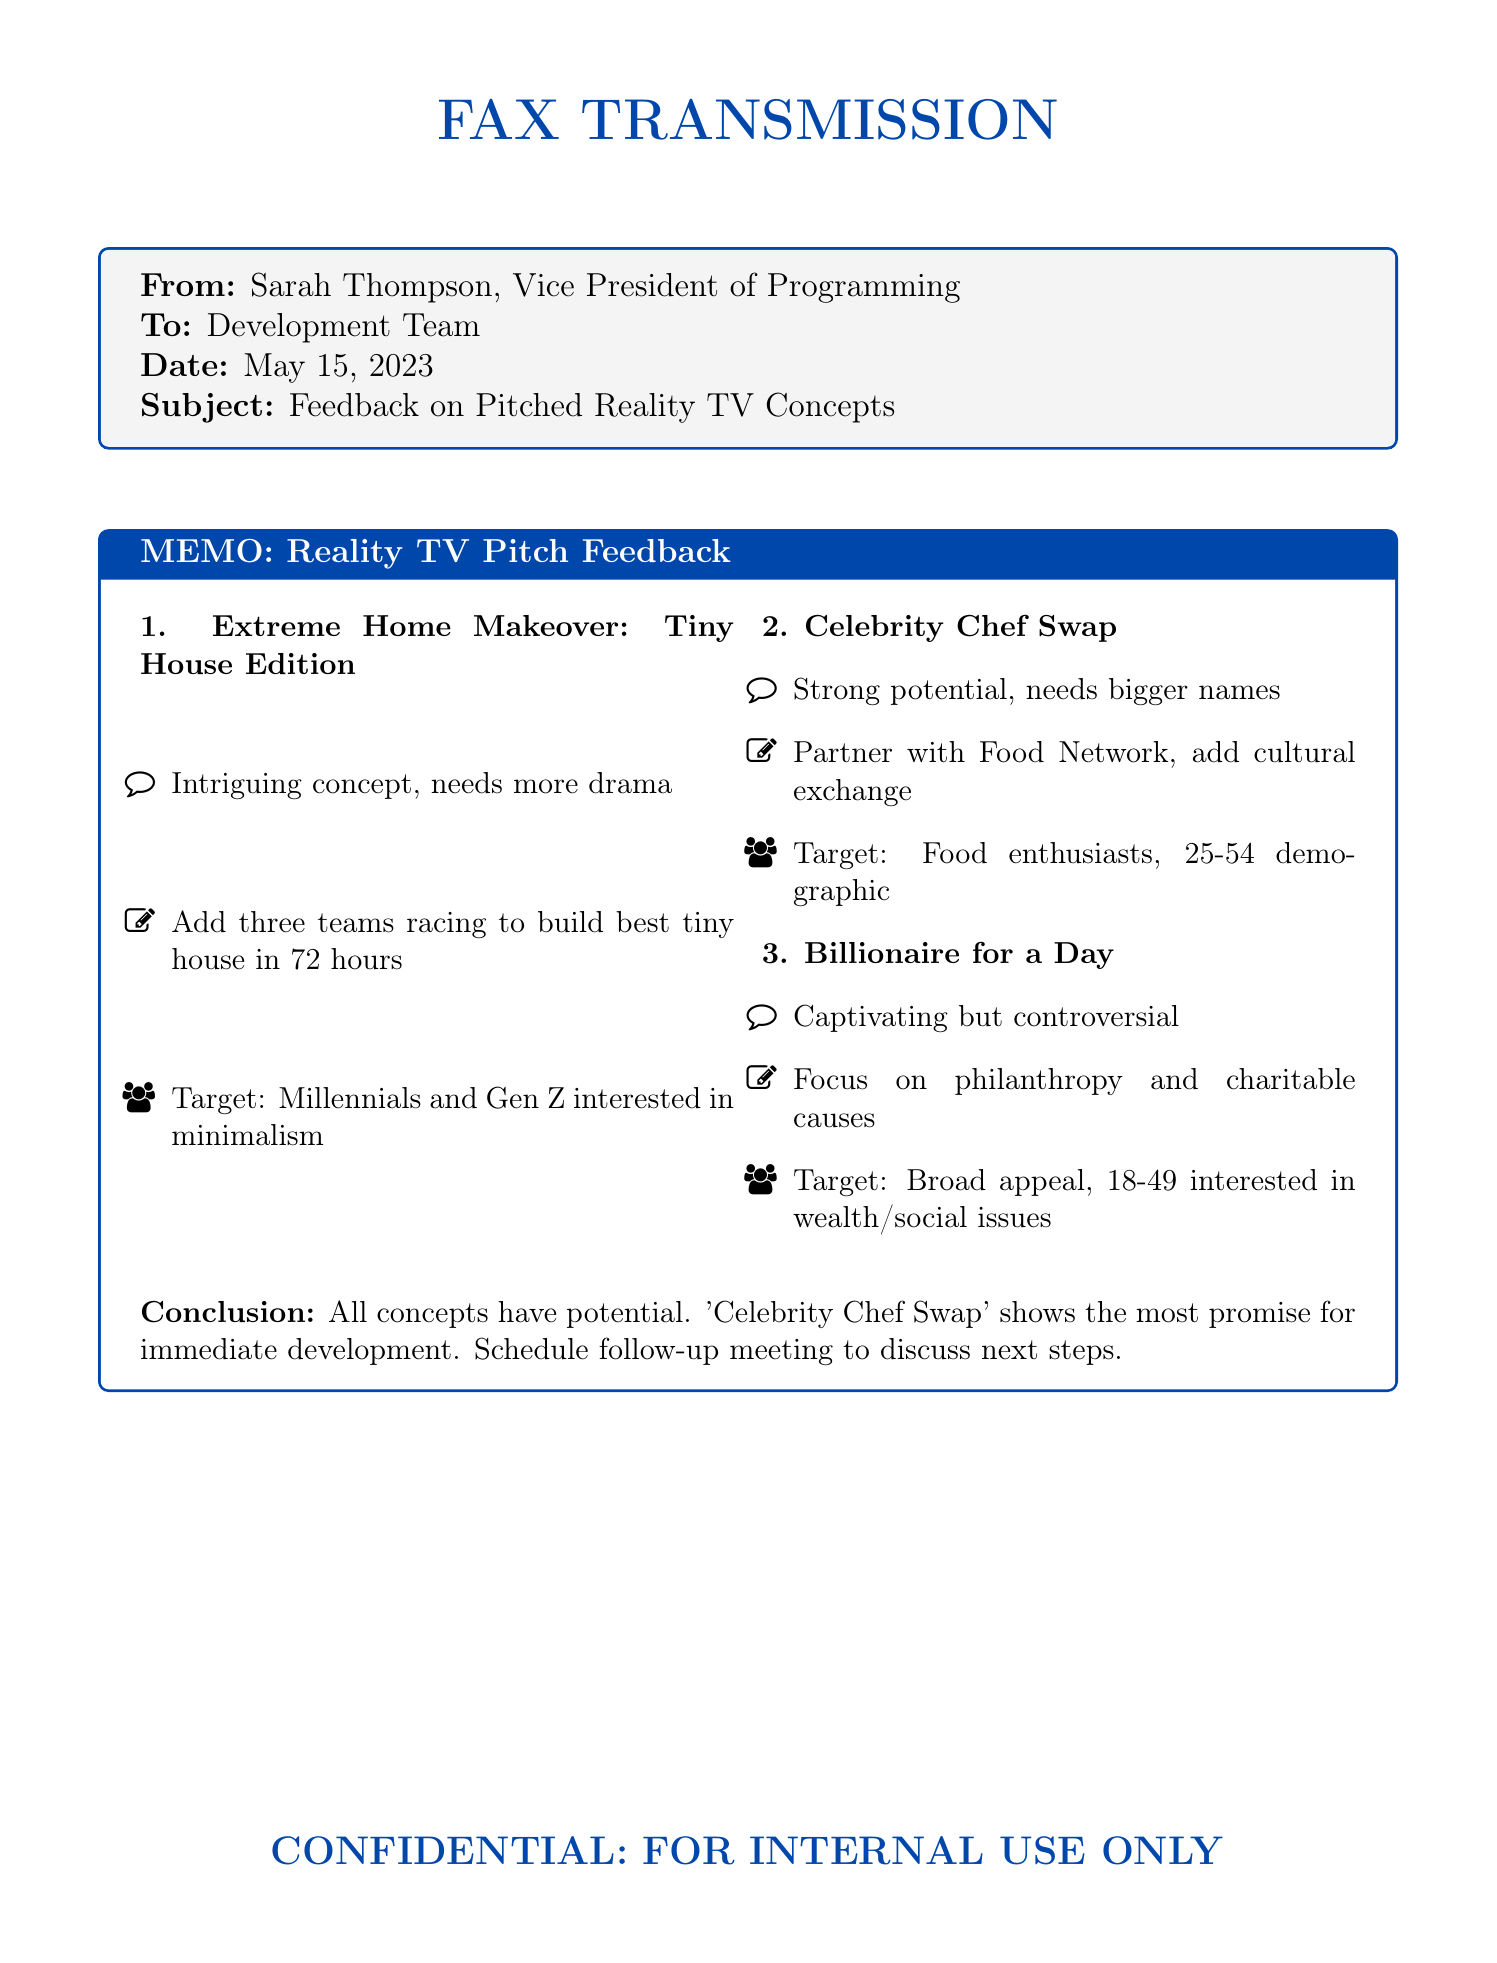What is the date of the fax? The date of the fax is mentioned in the header as May 15, 2023.
Answer: May 15, 2023 Who is the sender of the fax? The sender of the fax is listed at the top as Sarah Thompson, Vice President of Programming.
Answer: Sarah Thompson What is the first pitched reality TV concept? The first pitched reality TV concept is stated as "Extreme Home Makeover: Tiny House Edition".
Answer: Extreme Home Makeover: Tiny House Edition What audience does "Billionaire for a Day" target? The target audience for "Billionaire for a Day" is specified in the document as those interested in wealth and social issues, aged 18-49.
Answer: 18-49 interested in wealth/social issues What modification is suggested for "Celebrity Chef Swap"? The suggested modification for "Celebrity Chef Swap" is to partner with Food Network and add cultural exchange elements.
Answer: Partner with Food Network, add cultural exchange Which concept is recommended for immediate development? The conclusion indicates that "Celebrity Chef Swap" shows the most promise for immediate development.
Answer: Celebrity Chef Swap 